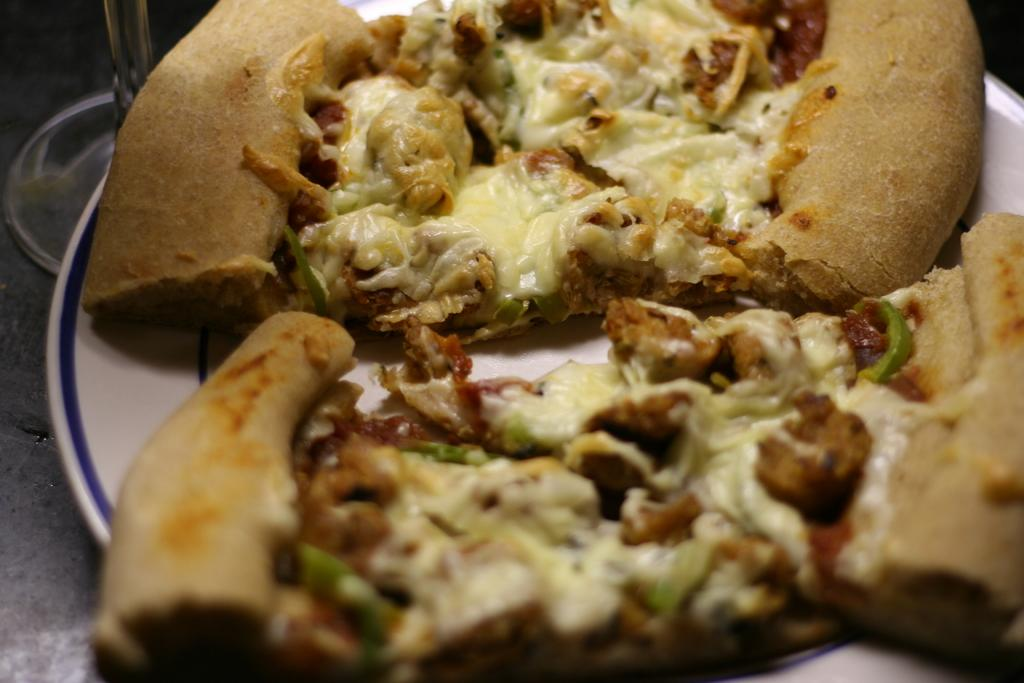What is on the plate in the image? There is food on the plate in the image. Where is the plate located in the image? The plate is placed on a surface in the image. What is beside the plate in the image? There is a glass beside the plate in the image. What type of rock is being operated on in the image? There is no rock or operation present in the image. 